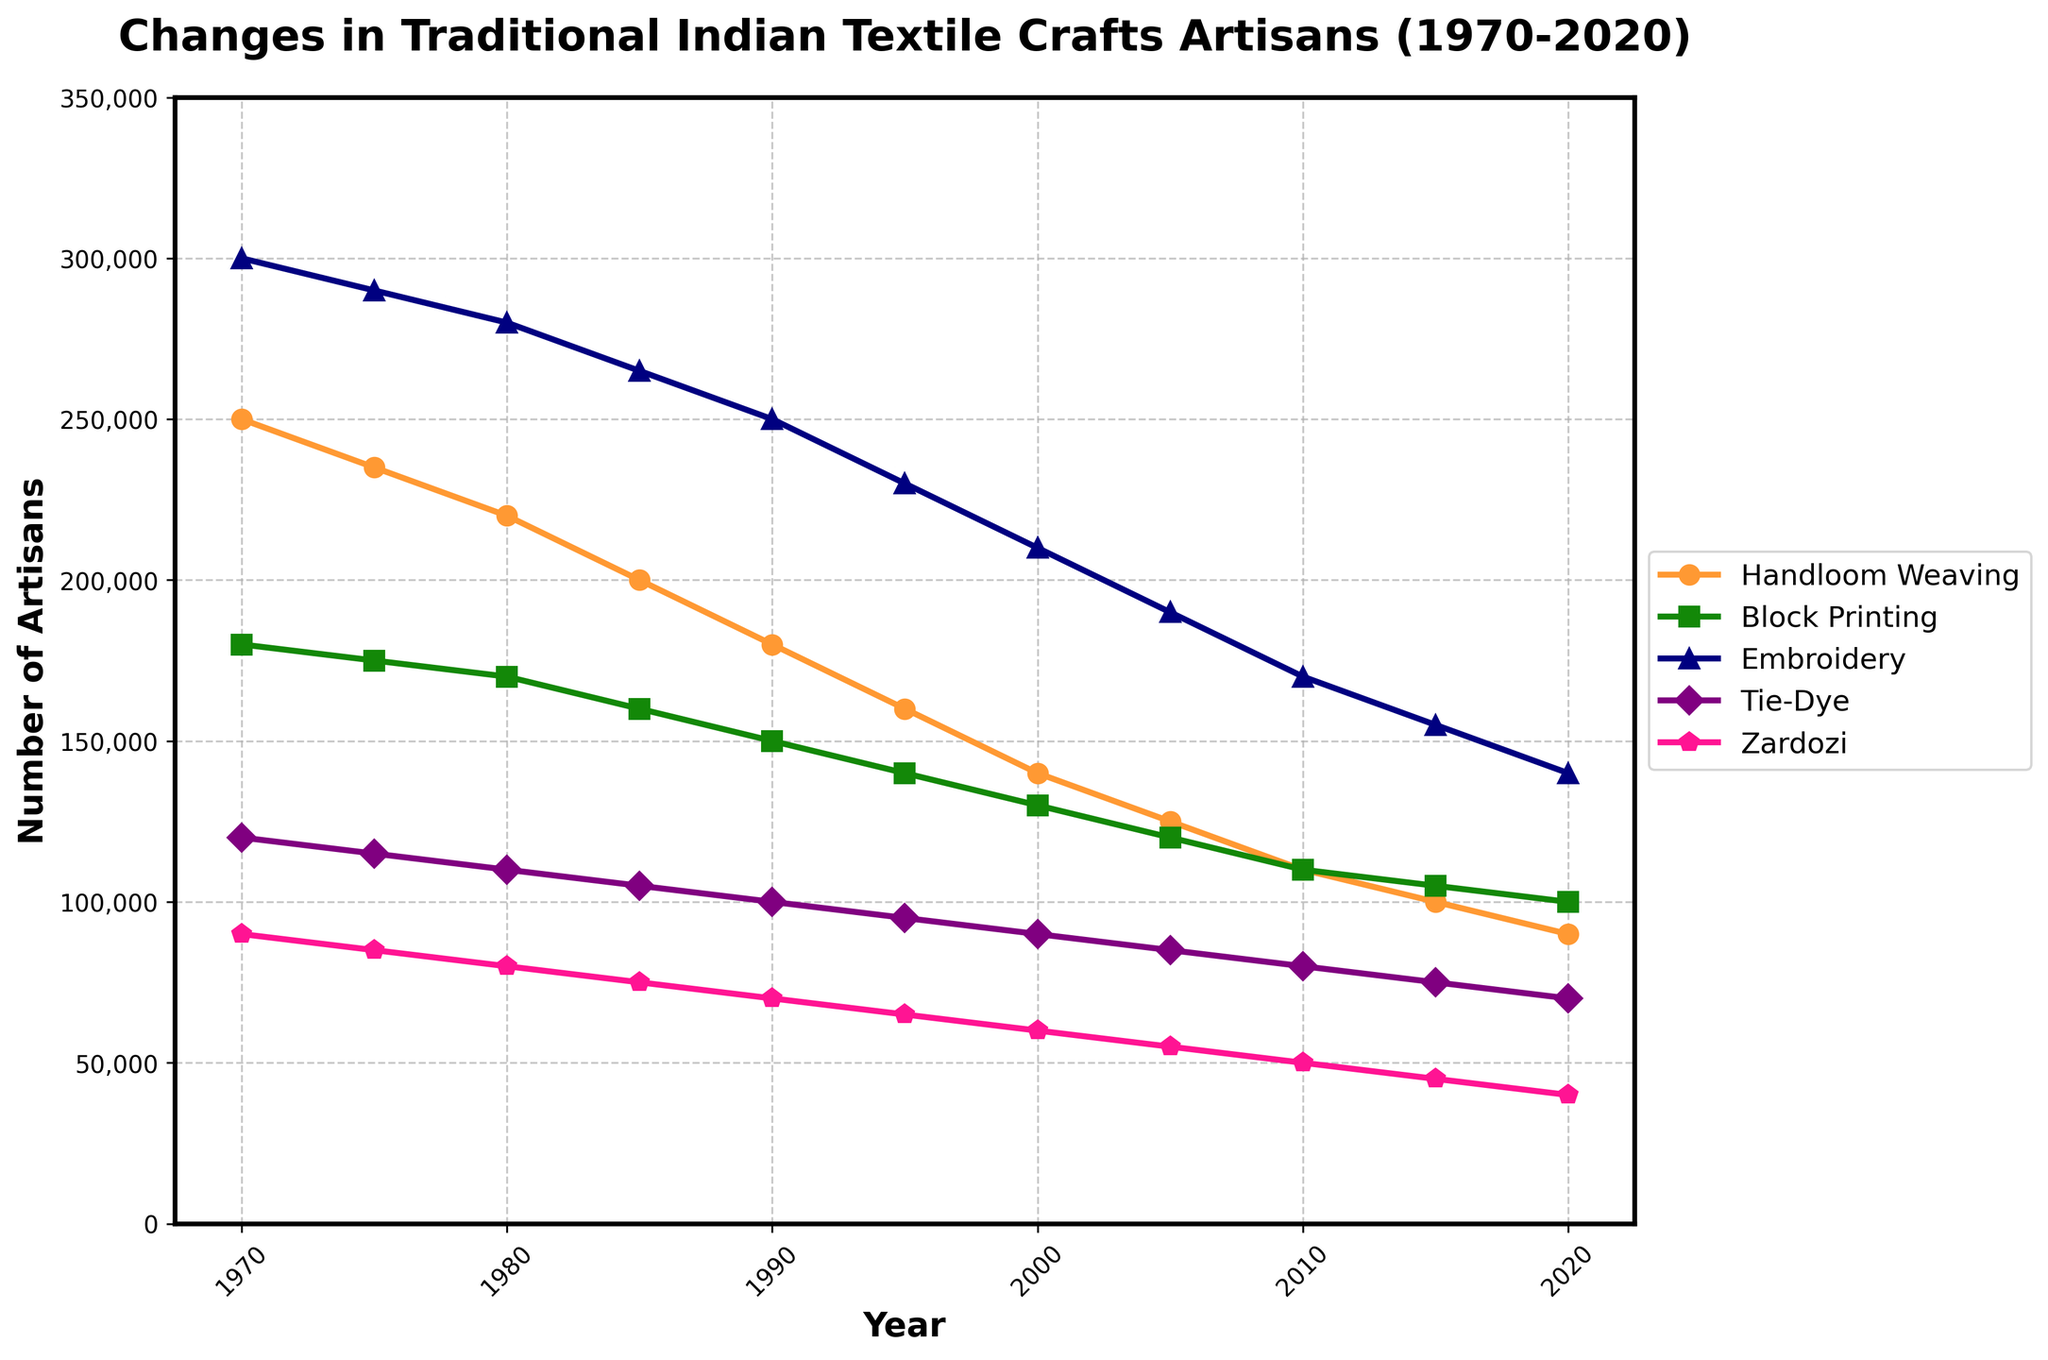Which craft type had the highest number of artisans in 1970? The line in the figure indicates that in 1970, 'Embroidery' had the highest number of artisans compared to the other craft types.
Answer: Embroidery How did the number of artisans practicing Handloom Weaving change from 1970 to 2020? In 1970, Handloom Weaving had 250,000 artisans, and by 2020 it decreased to 90,000 artisans. The change is 250,000 - 90,000 = 160,000. Thus, there was a decrease of 160,000 artisans.
Answer: Decreased by 160,000 Which craft type showed the smallest decline in the number of artisans from 1970 to 2020? Comparing all craft types, we see that 'Block Printing' started with 180,000 in 1970 and ended with 100,000 in 2020, resulting in a decline of 80,000. This decline is smaller than the others.
Answer: Block Printing Between which years did Embroidery see the largest decrease in artisans? Referring to the steepness of the line for Embroidery, the segment between 1985 (265,000) and 1990 (250,000) shows the largest decrease of 15,000 artisans.
Answer: 1985-1990 What is the combined number of artisans for Tie-Dye and Zardozi in 2020? Tie-Dye had 70,000 artisans and Zardozi had 40,000 in 2020. Summing them up, 70,000 + 40,000 = 110,000 artisans.
Answer: 110,000 Which craft type maintained the most consistent decline over the years? By visually inspecting the trend lines, 'Handloom Weaving' shows a relatively consistent decline without abrupt changes compared to the other crafts.
Answer: Handloom Weaving Between 1970 and 2020, which two crafts had the closest number of artisans in any given year? In 2020, 'Block Printing' had 100,000 artisans and 'Embroidery' had 140,000 artisans. The closest numbers appear around 2005 with 'Block Printing' at 120,000 and 'Tie-Dye' at 115,000.
Answer: Block Printing and Tie-Dye around 2005 Which year had the sharpest decline in the number of artisans for Zardozi compared to the previous year? The line graph shows that between 1970 and 1975, Zardozi dropped from 90,000 to 85,000, a decrease of 5,000. Reviewing all years, the largest drop is from 1995 to 2000, from 65,000 to 60,000—another decrease of 5,000.
Answer: 1995-2000 